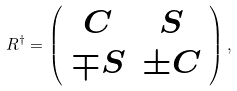Convert formula to latex. <formula><loc_0><loc_0><loc_500><loc_500>R ^ { \dagger } = \left ( \begin{array} { c c } C & S \\ \mp S & \pm C \end{array} \right ) ,</formula> 